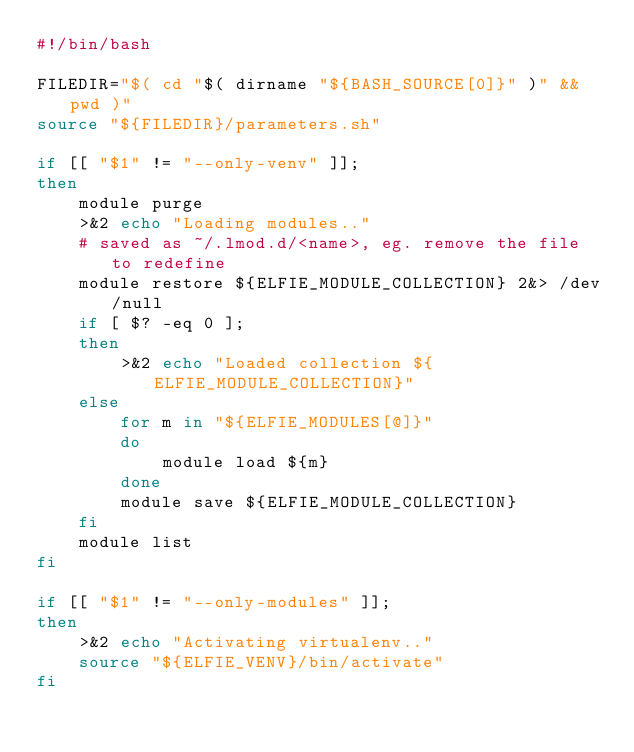Convert code to text. <code><loc_0><loc_0><loc_500><loc_500><_Bash_>#!/bin/bash

FILEDIR="$( cd "$( dirname "${BASH_SOURCE[0]}" )" && pwd )"
source "${FILEDIR}/parameters.sh"

if [[ "$1" != "--only-venv" ]];
then
    module purge
    >&2 echo "Loading modules.."
    # saved as ~/.lmod.d/<name>, eg. remove the file to redefine
    module restore ${ELFIE_MODULE_COLLECTION} 2&> /dev/null
    if [ $? -eq 0 ];
    then
        >&2 echo "Loaded collection ${ELFIE_MODULE_COLLECTION}"
    else
        for m in "${ELFIE_MODULES[@]}"
        do
            module load ${m}
        done
        module save ${ELFIE_MODULE_COLLECTION}
    fi
    module list
fi

if [[ "$1" != "--only-modules" ]];
then
    >&2 echo "Activating virtualenv.."
    source "${ELFIE_VENV}/bin/activate"
fi

</code> 